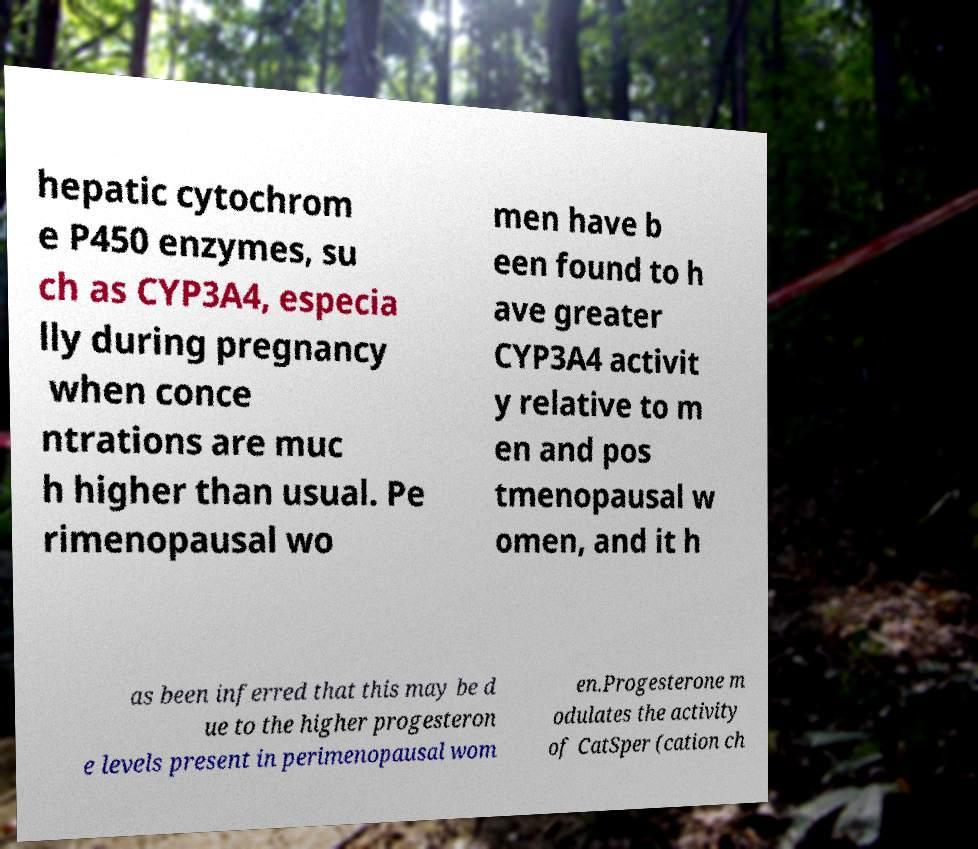Can you read and provide the text displayed in the image?This photo seems to have some interesting text. Can you extract and type it out for me? hepatic cytochrom e P450 enzymes, su ch as CYP3A4, especia lly during pregnancy when conce ntrations are muc h higher than usual. Pe rimenopausal wo men have b een found to h ave greater CYP3A4 activit y relative to m en and pos tmenopausal w omen, and it h as been inferred that this may be d ue to the higher progesteron e levels present in perimenopausal wom en.Progesterone m odulates the activity of CatSper (cation ch 